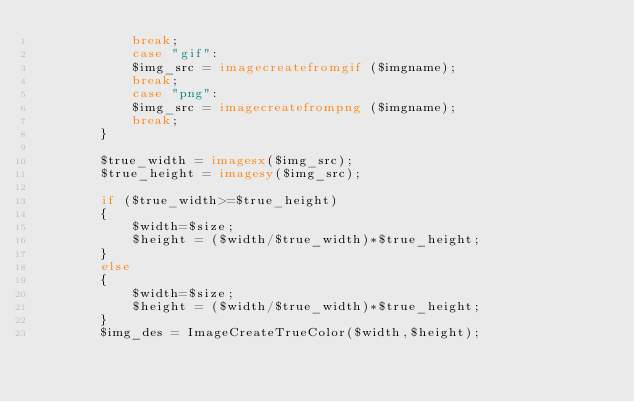Convert code to text. <code><loc_0><loc_0><loc_500><loc_500><_PHP_>			break;
			case "gif":
			$img_src = imagecreatefromgif ($imgname);
			break;
			case "png":
			$img_src = imagecreatefrompng ($imgname);
			break;
		}

		$true_width = imagesx($img_src);
		$true_height = imagesy($img_src);

		if ($true_width>=$true_height)
		{
			$width=$size;
			$height = ($width/$true_width)*$true_height;
		}
		else
		{
			$width=$size;
			$height = ($width/$true_width)*$true_height;
		}
		$img_des = ImageCreateTrueColor($width,$height);
		</code> 